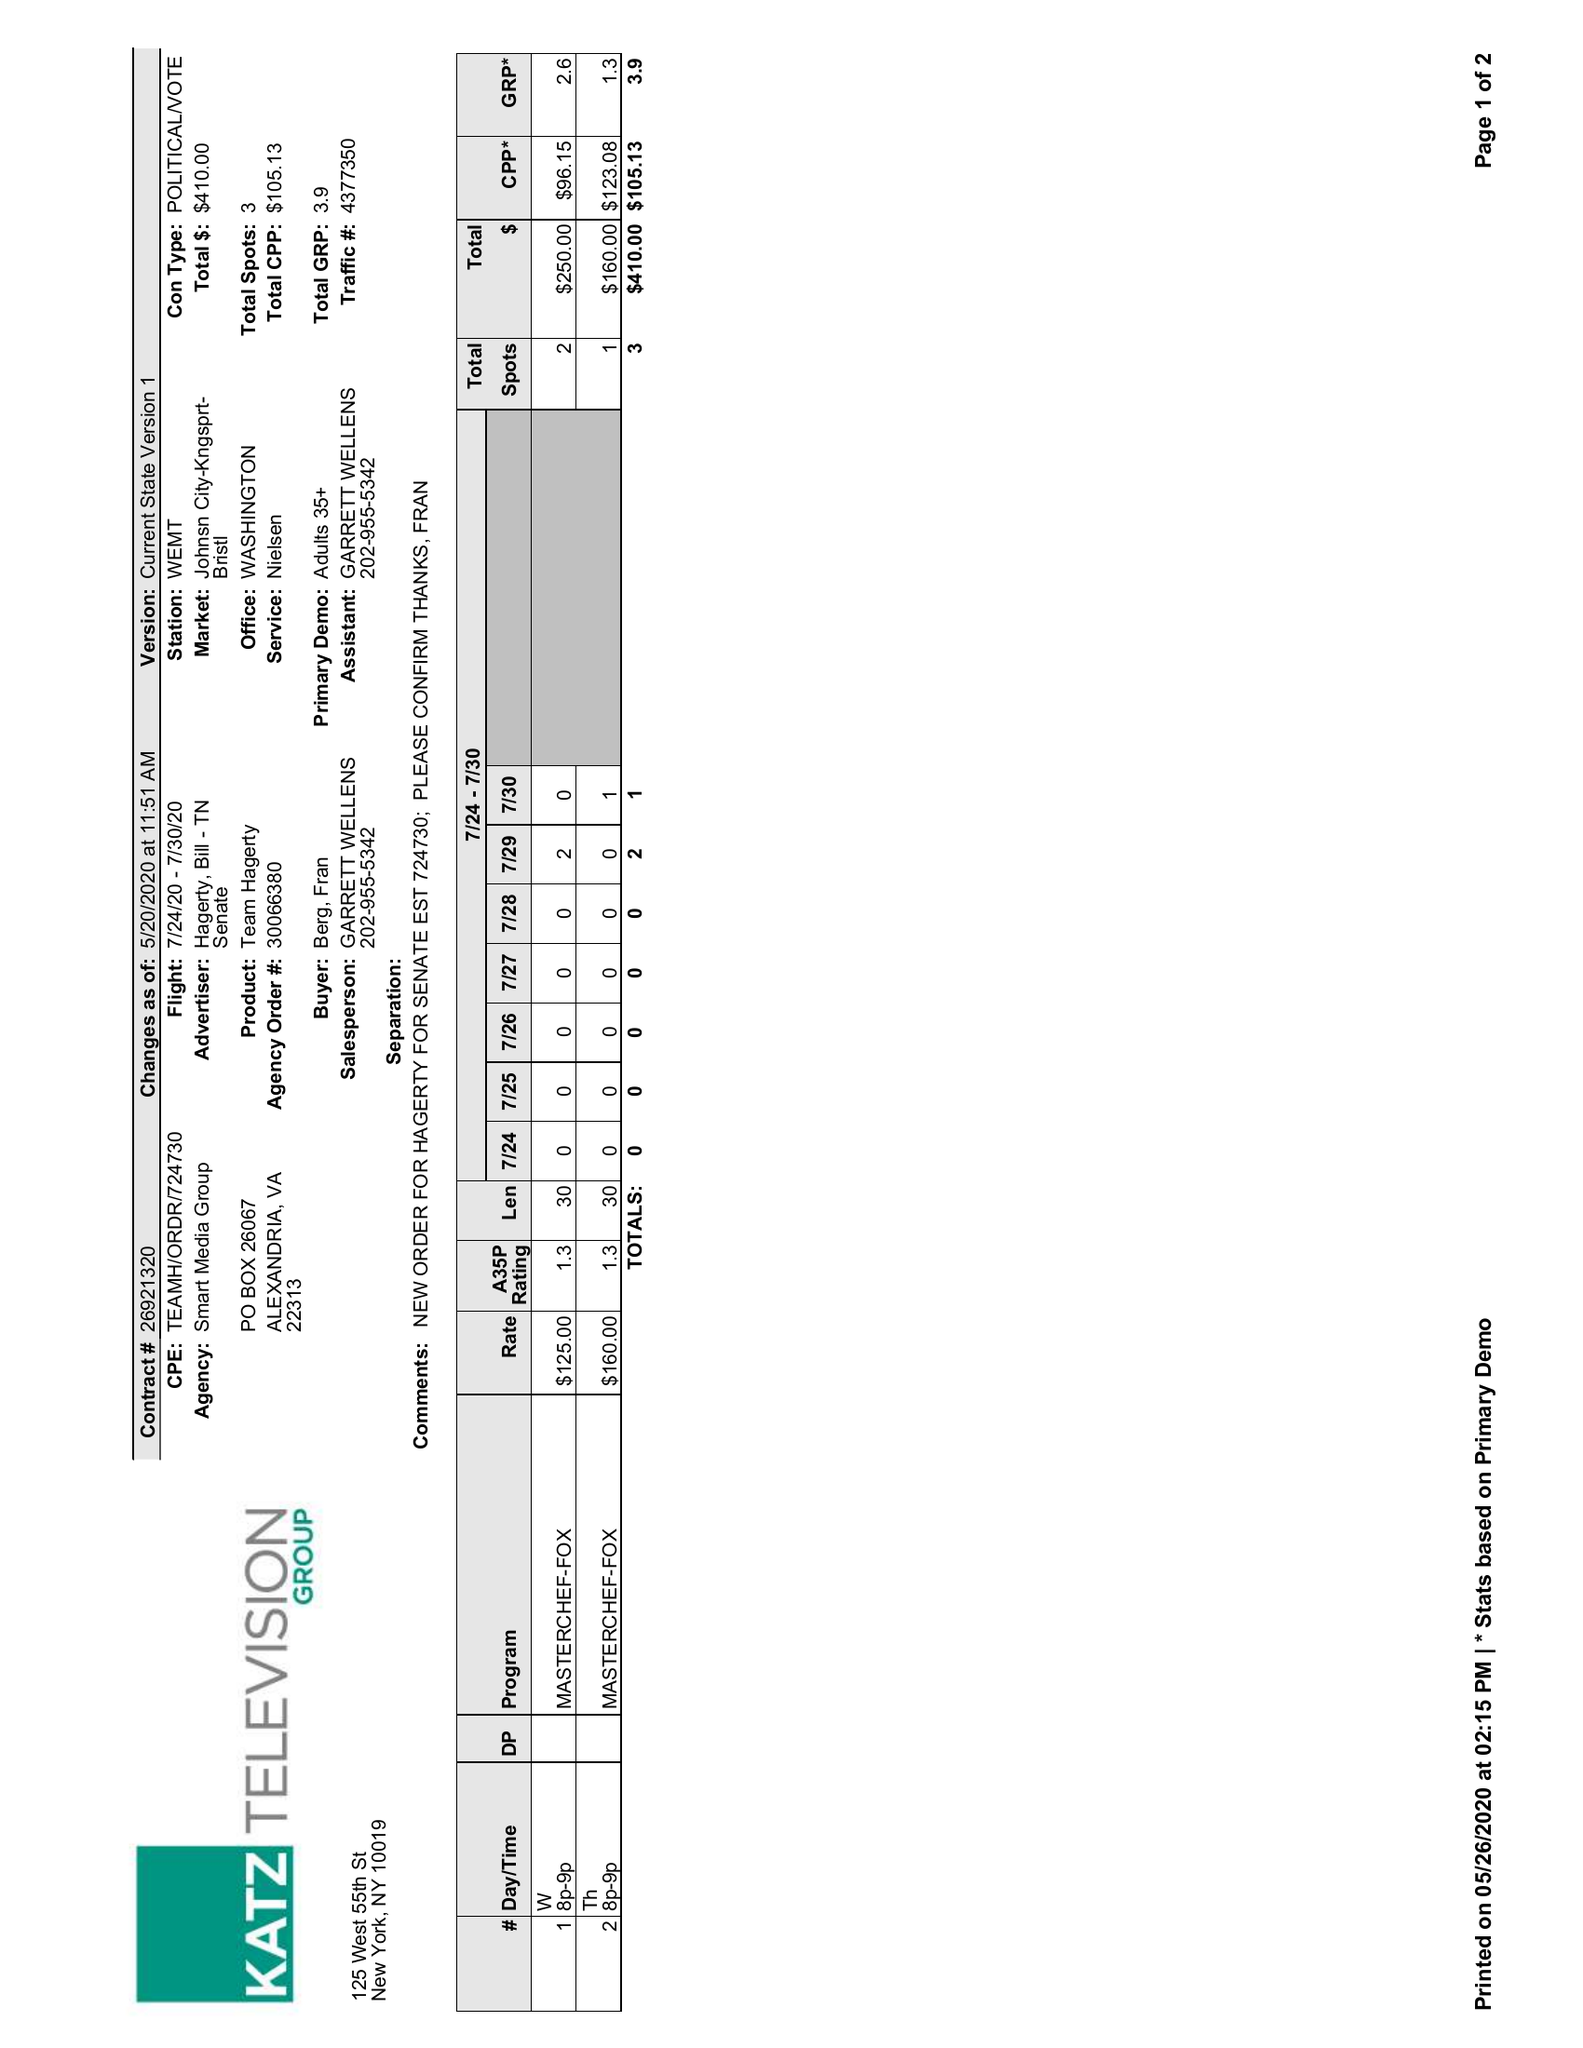What is the value for the contract_num?
Answer the question using a single word or phrase. 26921320 